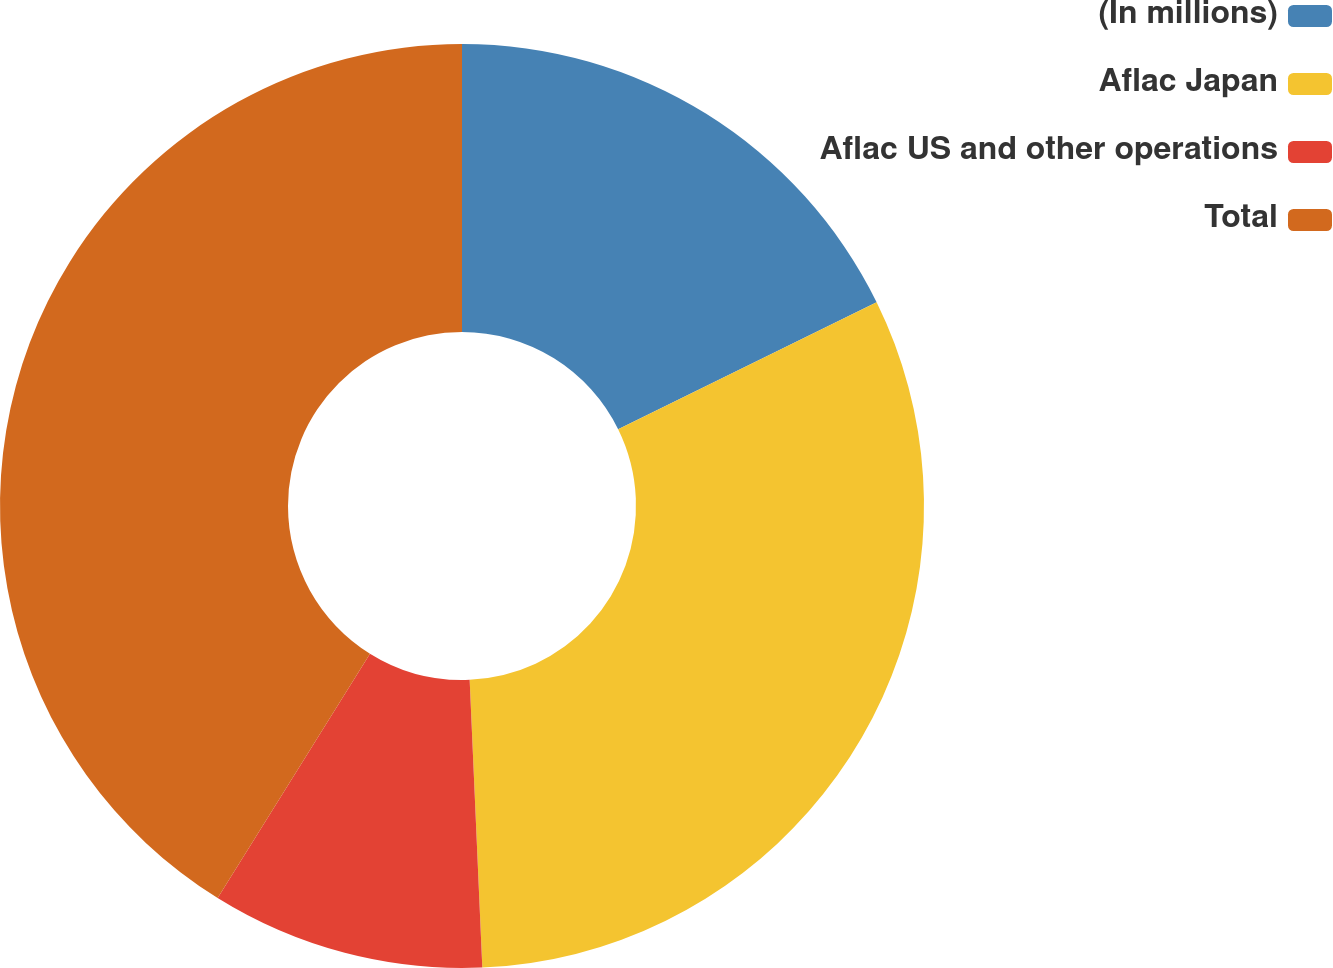Convert chart. <chart><loc_0><loc_0><loc_500><loc_500><pie_chart><fcel>(In millions)<fcel>Aflac Japan<fcel>Aflac US and other operations<fcel>Total<nl><fcel>17.73%<fcel>31.57%<fcel>9.57%<fcel>41.13%<nl></chart> 